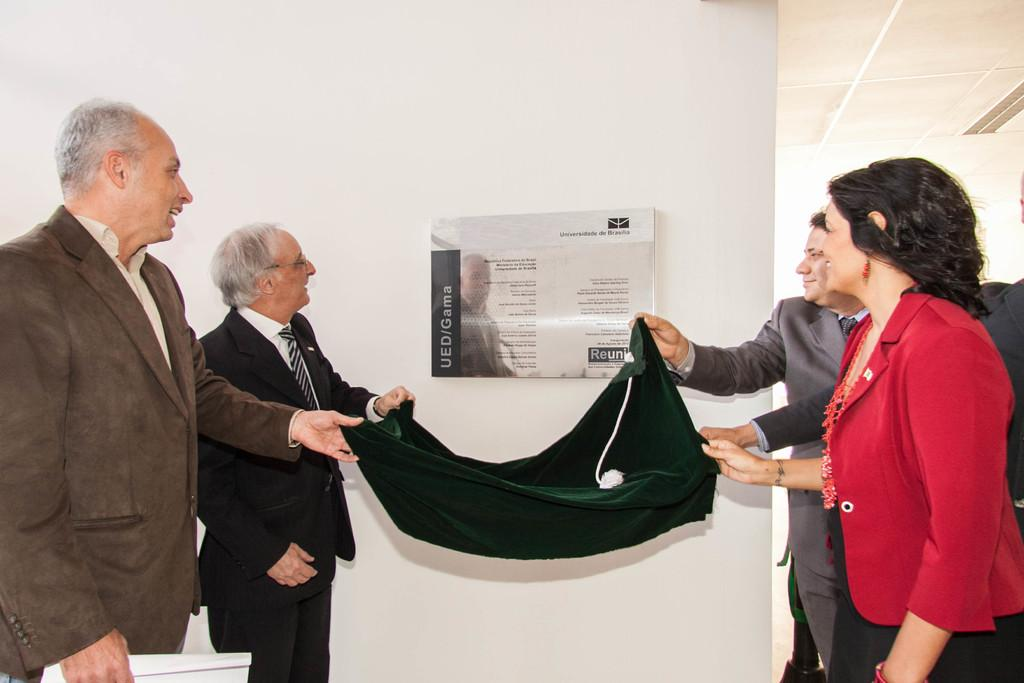What is the color of the wall in the image? The wall in the image is white. What can be seen hanging on the wall? There is a banner in the image. Who or what is present in the image besides the wall and banner? There are people in the image. What are the people holding in the image? The people are holding black color cloth. How many bats are hanging from the ceiling in the image? There are no bats present in the image; it only features a wall, a banner, people, and black cloth. 